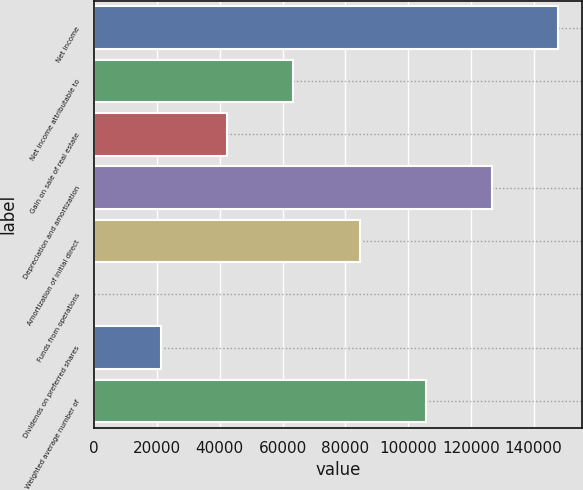Convert chart to OTSL. <chart><loc_0><loc_0><loc_500><loc_500><bar_chart><fcel>Net income<fcel>Net income attributable to<fcel>Gain on sale of real estate<fcel>Depreciation and amortization<fcel>Amortization of initial direct<fcel>Funds from operations<fcel>Dividends on preferred shares<fcel>Weighted average number of<nl><fcel>147924<fcel>63398.2<fcel>42266.6<fcel>126793<fcel>84529.7<fcel>3.51<fcel>21135.1<fcel>105661<nl></chart> 